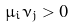<formula> <loc_0><loc_0><loc_500><loc_500>\mu _ { i } \nu _ { j } > 0</formula> 